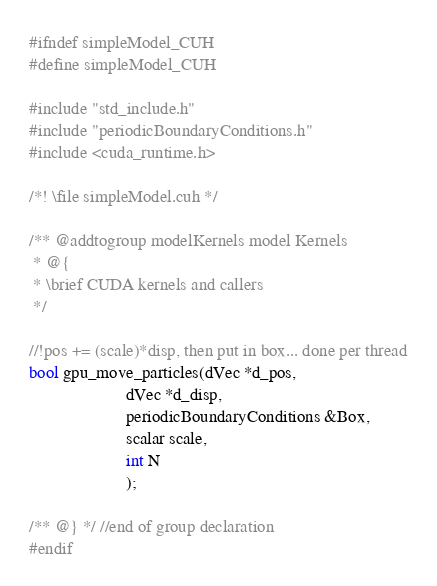Convert code to text. <code><loc_0><loc_0><loc_500><loc_500><_Cuda_>#ifndef simpleModel_CUH
#define simpleModel_CUH

#include "std_include.h"
#include "periodicBoundaryConditions.h"
#include <cuda_runtime.h>

/*! \file simpleModel.cuh */

/** @addtogroup modelKernels model Kernels
 * @{
 * \brief CUDA kernels and callers
 */

//!pos += (scale)*disp, then put in box... done per thread
bool gpu_move_particles(dVec *d_pos,
                      dVec *d_disp,
                      periodicBoundaryConditions &Box,
                      scalar scale,
                      int N
                      );

/** @} */ //end of group declaration
#endif
</code> 